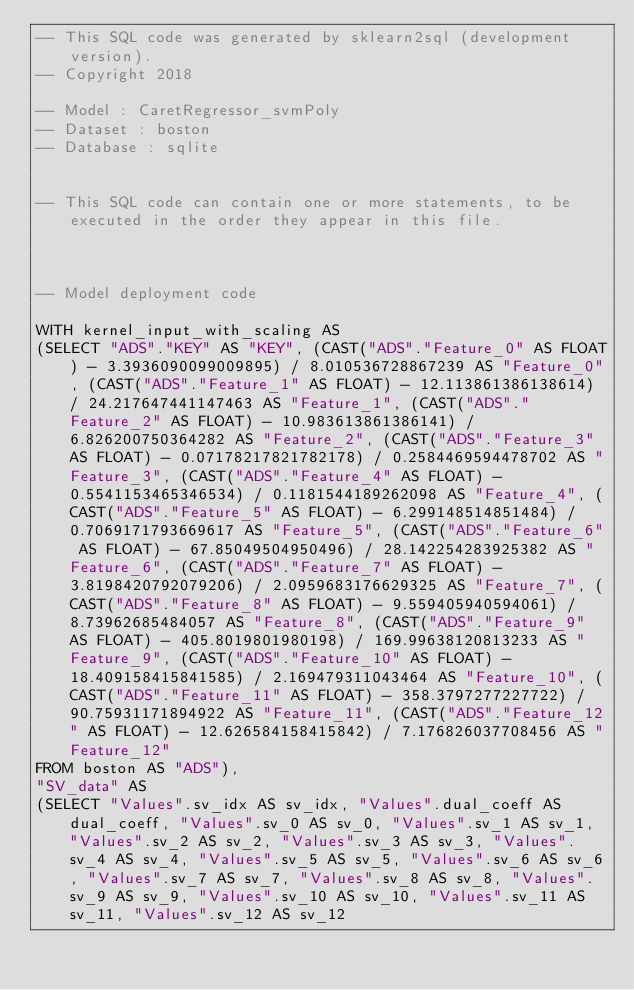Convert code to text. <code><loc_0><loc_0><loc_500><loc_500><_SQL_>-- This SQL code was generated by sklearn2sql (development version).
-- Copyright 2018

-- Model : CaretRegressor_svmPoly
-- Dataset : boston
-- Database : sqlite


-- This SQL code can contain one or more statements, to be executed in the order they appear in this file.



-- Model deployment code

WITH kernel_input_with_scaling AS 
(SELECT "ADS"."KEY" AS "KEY", (CAST("ADS"."Feature_0" AS FLOAT) - 3.3936090099009895) / 8.010536728867239 AS "Feature_0", (CAST("ADS"."Feature_1" AS FLOAT) - 12.113861386138614) / 24.217647441147463 AS "Feature_1", (CAST("ADS"."Feature_2" AS FLOAT) - 10.983613861386141) / 6.826200750364282 AS "Feature_2", (CAST("ADS"."Feature_3" AS FLOAT) - 0.07178217821782178) / 0.2584469594478702 AS "Feature_3", (CAST("ADS"."Feature_4" AS FLOAT) - 0.5541153465346534) / 0.1181544189262098 AS "Feature_4", (CAST("ADS"."Feature_5" AS FLOAT) - 6.299148514851484) / 0.7069171793669617 AS "Feature_5", (CAST("ADS"."Feature_6" AS FLOAT) - 67.85049504950496) / 28.142254283925382 AS "Feature_6", (CAST("ADS"."Feature_7" AS FLOAT) - 3.8198420792079206) / 2.0959683176629325 AS "Feature_7", (CAST("ADS"."Feature_8" AS FLOAT) - 9.559405940594061) / 8.73962685484057 AS "Feature_8", (CAST("ADS"."Feature_9" AS FLOAT) - 405.8019801980198) / 169.99638120813233 AS "Feature_9", (CAST("ADS"."Feature_10" AS FLOAT) - 18.409158415841585) / 2.169479311043464 AS "Feature_10", (CAST("ADS"."Feature_11" AS FLOAT) - 358.3797277227722) / 90.75931171894922 AS "Feature_11", (CAST("ADS"."Feature_12" AS FLOAT) - 12.626584158415842) / 7.176826037708456 AS "Feature_12" 
FROM boston AS "ADS"), 
"SV_data" AS 
(SELECT "Values".sv_idx AS sv_idx, "Values".dual_coeff AS dual_coeff, "Values".sv_0 AS sv_0, "Values".sv_1 AS sv_1, "Values".sv_2 AS sv_2, "Values".sv_3 AS sv_3, "Values".sv_4 AS sv_4, "Values".sv_5 AS sv_5, "Values".sv_6 AS sv_6, "Values".sv_7 AS sv_7, "Values".sv_8 AS sv_8, "Values".sv_9 AS sv_9, "Values".sv_10 AS sv_10, "Values".sv_11 AS sv_11, "Values".sv_12 AS sv_12 </code> 